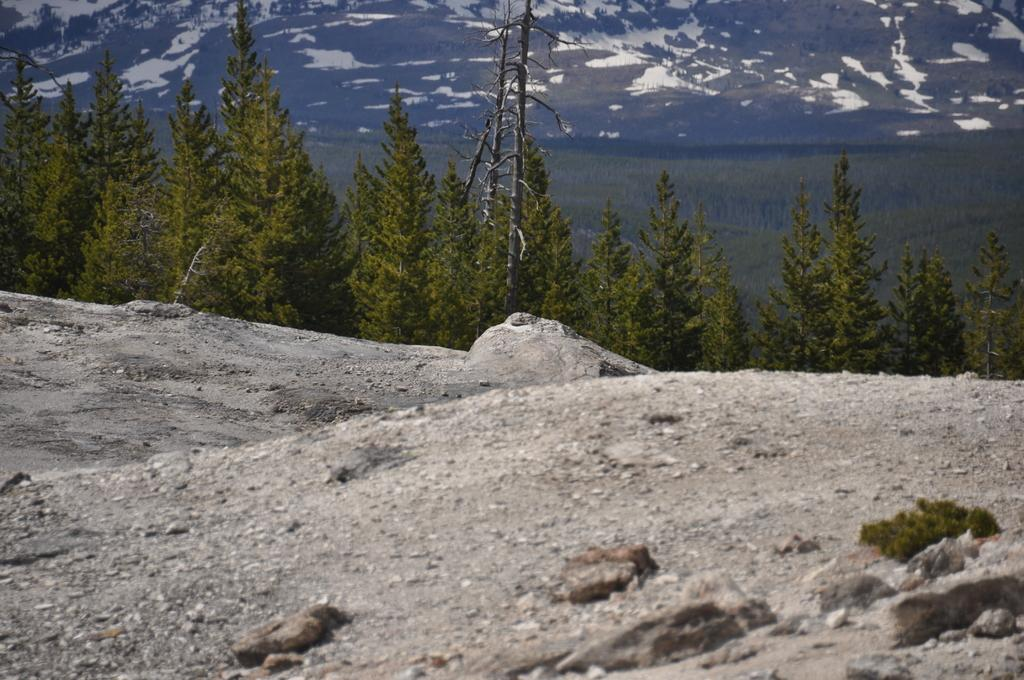What type of terrain is visible at the bottom of the image? There are stones and a rock surface at the bottom of the image. What can be seen in the middle of the image? There are trees in the middle of the image. What is visible in the background of the image? There are trees and hills in the background of the image. What is the belief of the trees in the image? There is no indication of any beliefs in the image, as trees are inanimate objects and do not have beliefs. How do the trees in the image wash their leaves? Trees do not wash their leaves; they rely on natural processes such as rain and wind to clean their leaves. 